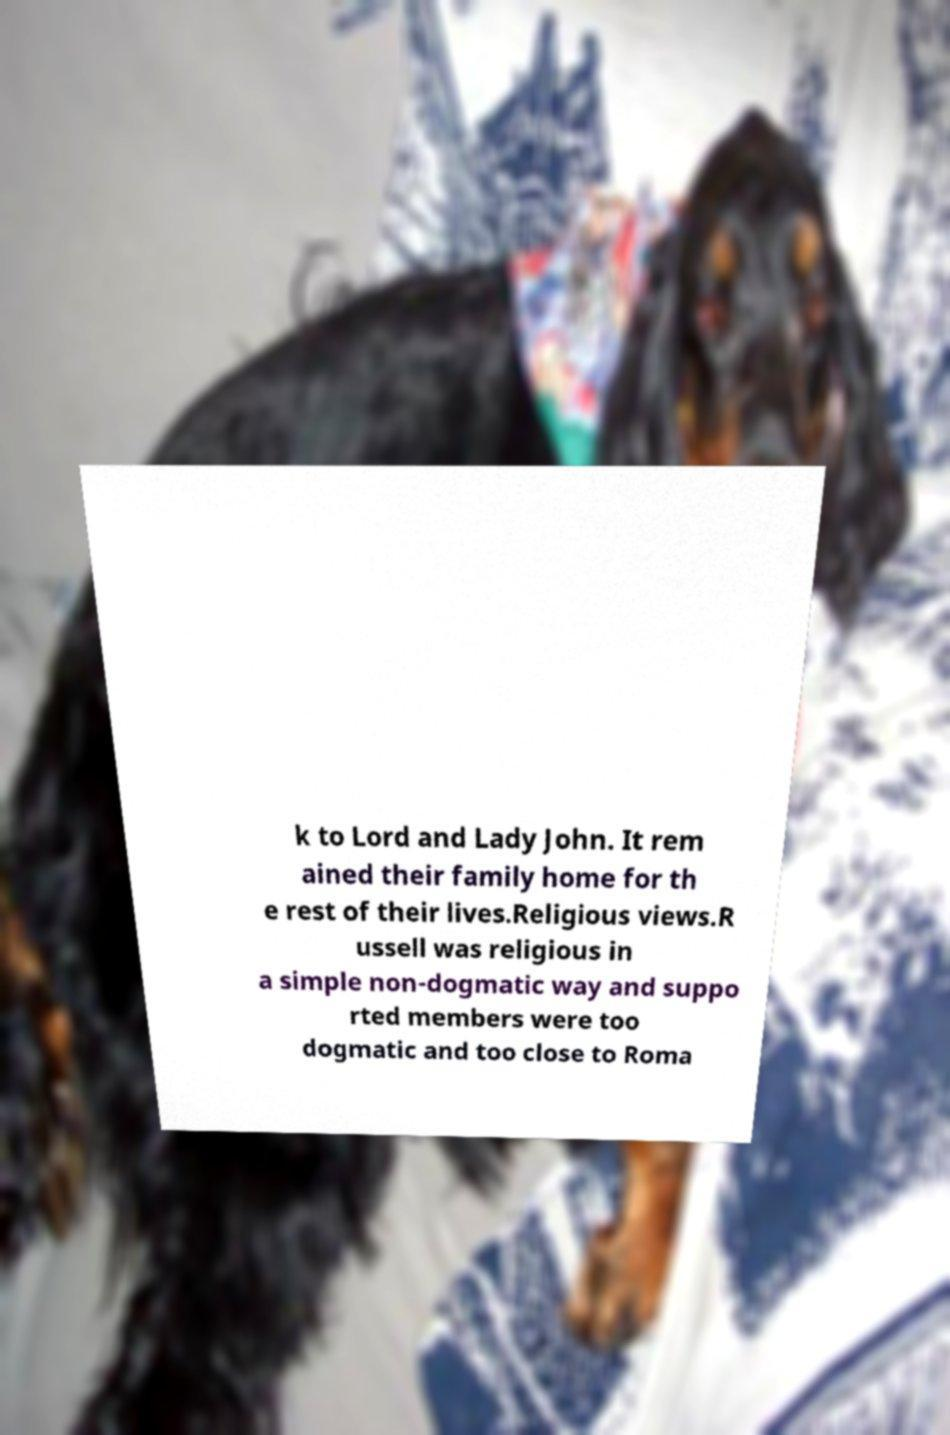Can you accurately transcribe the text from the provided image for me? k to Lord and Lady John. It rem ained their family home for th e rest of their lives.Religious views.R ussell was religious in a simple non-dogmatic way and suppo rted members were too dogmatic and too close to Roma 